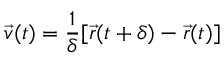<formula> <loc_0><loc_0><loc_500><loc_500>\vec { v } ( t ) = \frac { 1 } { \delta } [ \vec { r } ( t + \delta ) - \vec { r } ( t ) ]</formula> 